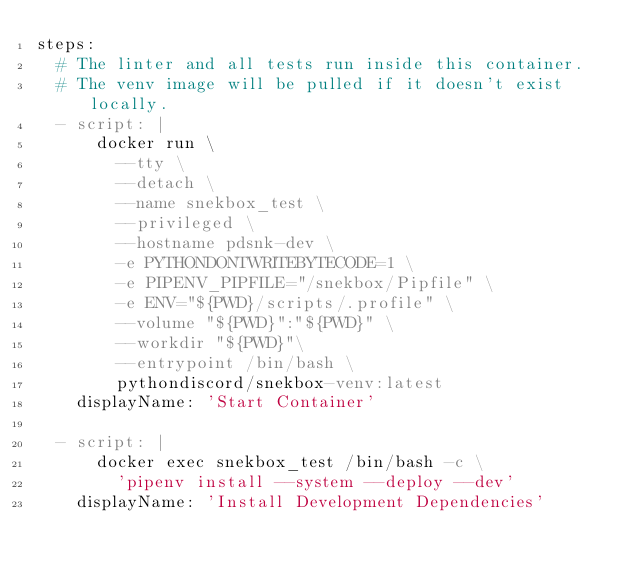Convert code to text. <code><loc_0><loc_0><loc_500><loc_500><_YAML_>steps:
  # The linter and all tests run inside this container.
  # The venv image will be pulled if it doesn't exist locally.
  - script: |
      docker run \
        --tty \
        --detach \
        --name snekbox_test \
        --privileged \
        --hostname pdsnk-dev \
        -e PYTHONDONTWRITEBYTECODE=1 \
        -e PIPENV_PIPFILE="/snekbox/Pipfile" \
        -e ENV="${PWD}/scripts/.profile" \
        --volume "${PWD}":"${PWD}" \
        --workdir "${PWD}"\
        --entrypoint /bin/bash \
        pythondiscord/snekbox-venv:latest
    displayName: 'Start Container'

  - script: |
      docker exec snekbox_test /bin/bash -c \
        'pipenv install --system --deploy --dev'
    displayName: 'Install Development Dependencies'
</code> 